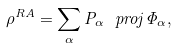Convert formula to latex. <formula><loc_0><loc_0><loc_500><loc_500>\rho ^ { R A } = \sum _ { \alpha } P _ { \alpha } \ p r o j { \Phi _ { \alpha } } ,</formula> 